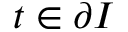<formula> <loc_0><loc_0><loc_500><loc_500>t \in \partial I</formula> 